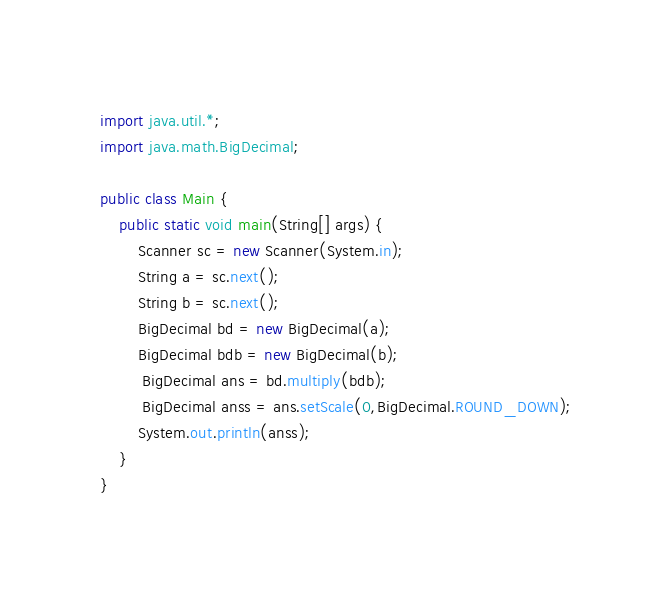<code> <loc_0><loc_0><loc_500><loc_500><_Java_>import java.util.*;
import java.math.BigDecimal;

public class Main {
    public static void main(String[] args) {
        Scanner sc = new Scanner(System.in);
        String a = sc.next();
        String b = sc.next();
        BigDecimal bd = new BigDecimal(a);
        BigDecimal bdb = new BigDecimal(b);
         BigDecimal ans = bd.multiply(bdb);
         BigDecimal anss = ans.setScale(0,BigDecimal.ROUND_DOWN);
        System.out.println(anss);
    }
}
</code> 